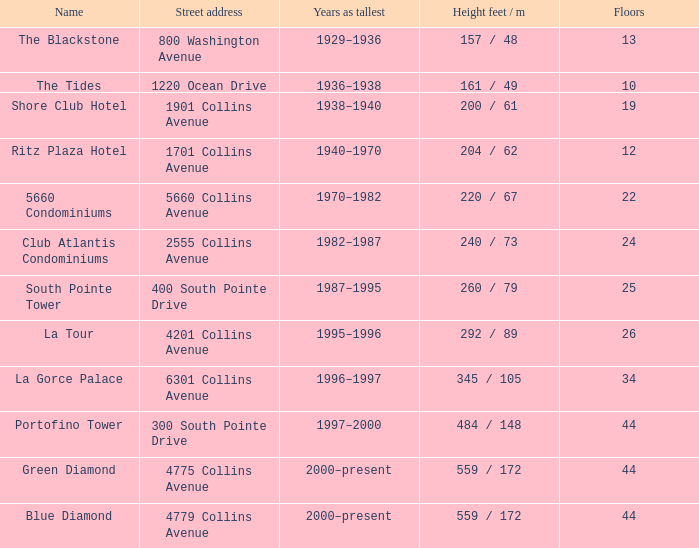Parse the full table. {'header': ['Name', 'Street address', 'Years as tallest', 'Height feet / m', 'Floors'], 'rows': [['The Blackstone', '800 Washington Avenue', '1929–1936', '157 / 48', '13'], ['The Tides', '1220 Ocean Drive', '1936–1938', '161 / 49', '10'], ['Shore Club Hotel', '1901 Collins Avenue', '1938–1940', '200 / 61', '19'], ['Ritz Plaza Hotel', '1701 Collins Avenue', '1940–1970', '204 / 62', '12'], ['5660 Condominiums', '5660 Collins Avenue', '1970–1982', '220 / 67', '22'], ['Club Atlantis Condominiums', '2555 Collins Avenue', '1982–1987', '240 / 73', '24'], ['South Pointe Tower', '400 South Pointe Drive', '1987–1995', '260 / 79', '25'], ['La Tour', '4201 Collins Avenue', '1995–1996', '292 / 89', '26'], ['La Gorce Palace', '6301 Collins Avenue', '1996–1997', '345 / 105', '34'], ['Portofino Tower', '300 South Pointe Drive', '1997–2000', '484 / 148', '44'], ['Green Diamond', '4775 Collins Avenue', '2000–present', '559 / 172', '44'], ['Blue Diamond', '4779 Collins Avenue', '2000–present', '559 / 172', '44']]} How many floors does the Blue Diamond have? 44.0. 